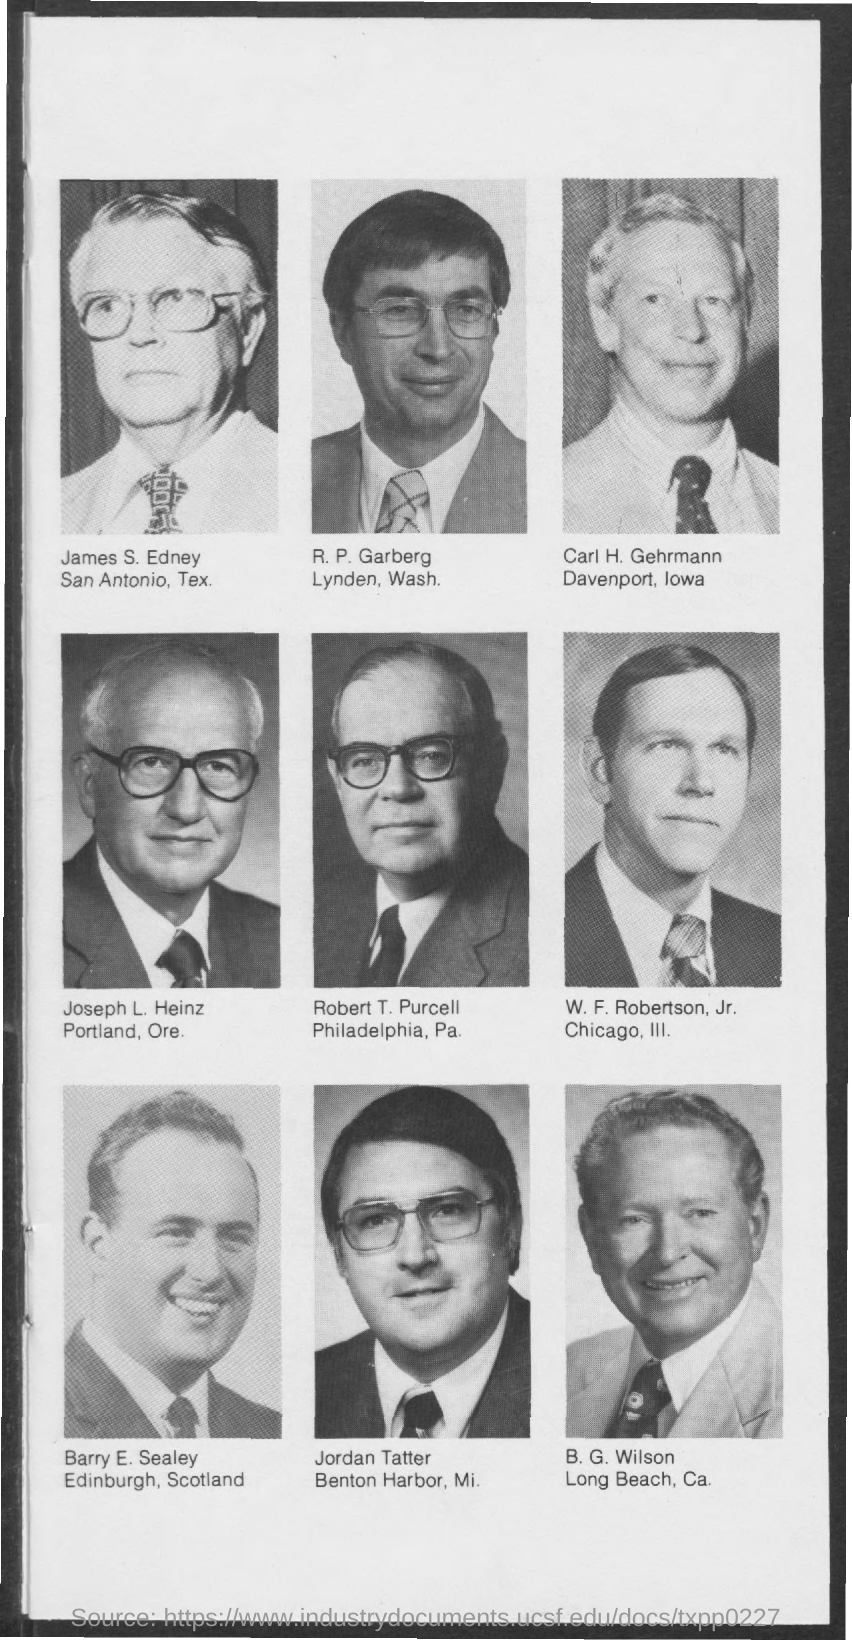Barry E. Sealey is from which place?
Give a very brief answer. Edinburgh. 